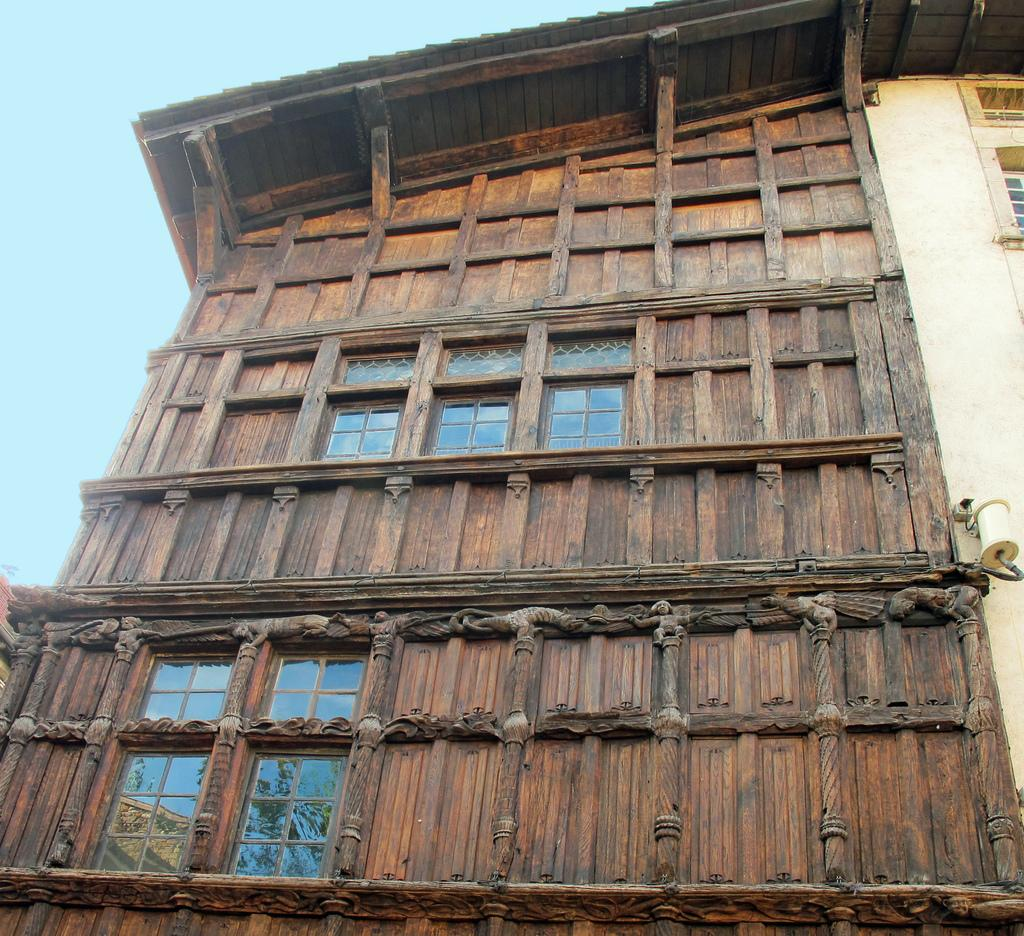What type of structure is present in the image? There is a building in the image. What material is used for the wall of the building? The building has a wooden wall. What feature allows light to enter the building? The building has windows. What can be seen in the background of the image? The sky is visible in the background of the image. Where is the crowd gathered in the image? There is no crowd present in the image; it only features a building with a wooden wall, windows, and a visible sky in the background. 